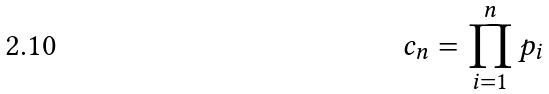Convert formula to latex. <formula><loc_0><loc_0><loc_500><loc_500>c _ { n } = \prod _ { i = 1 } ^ { n } p _ { i }</formula> 